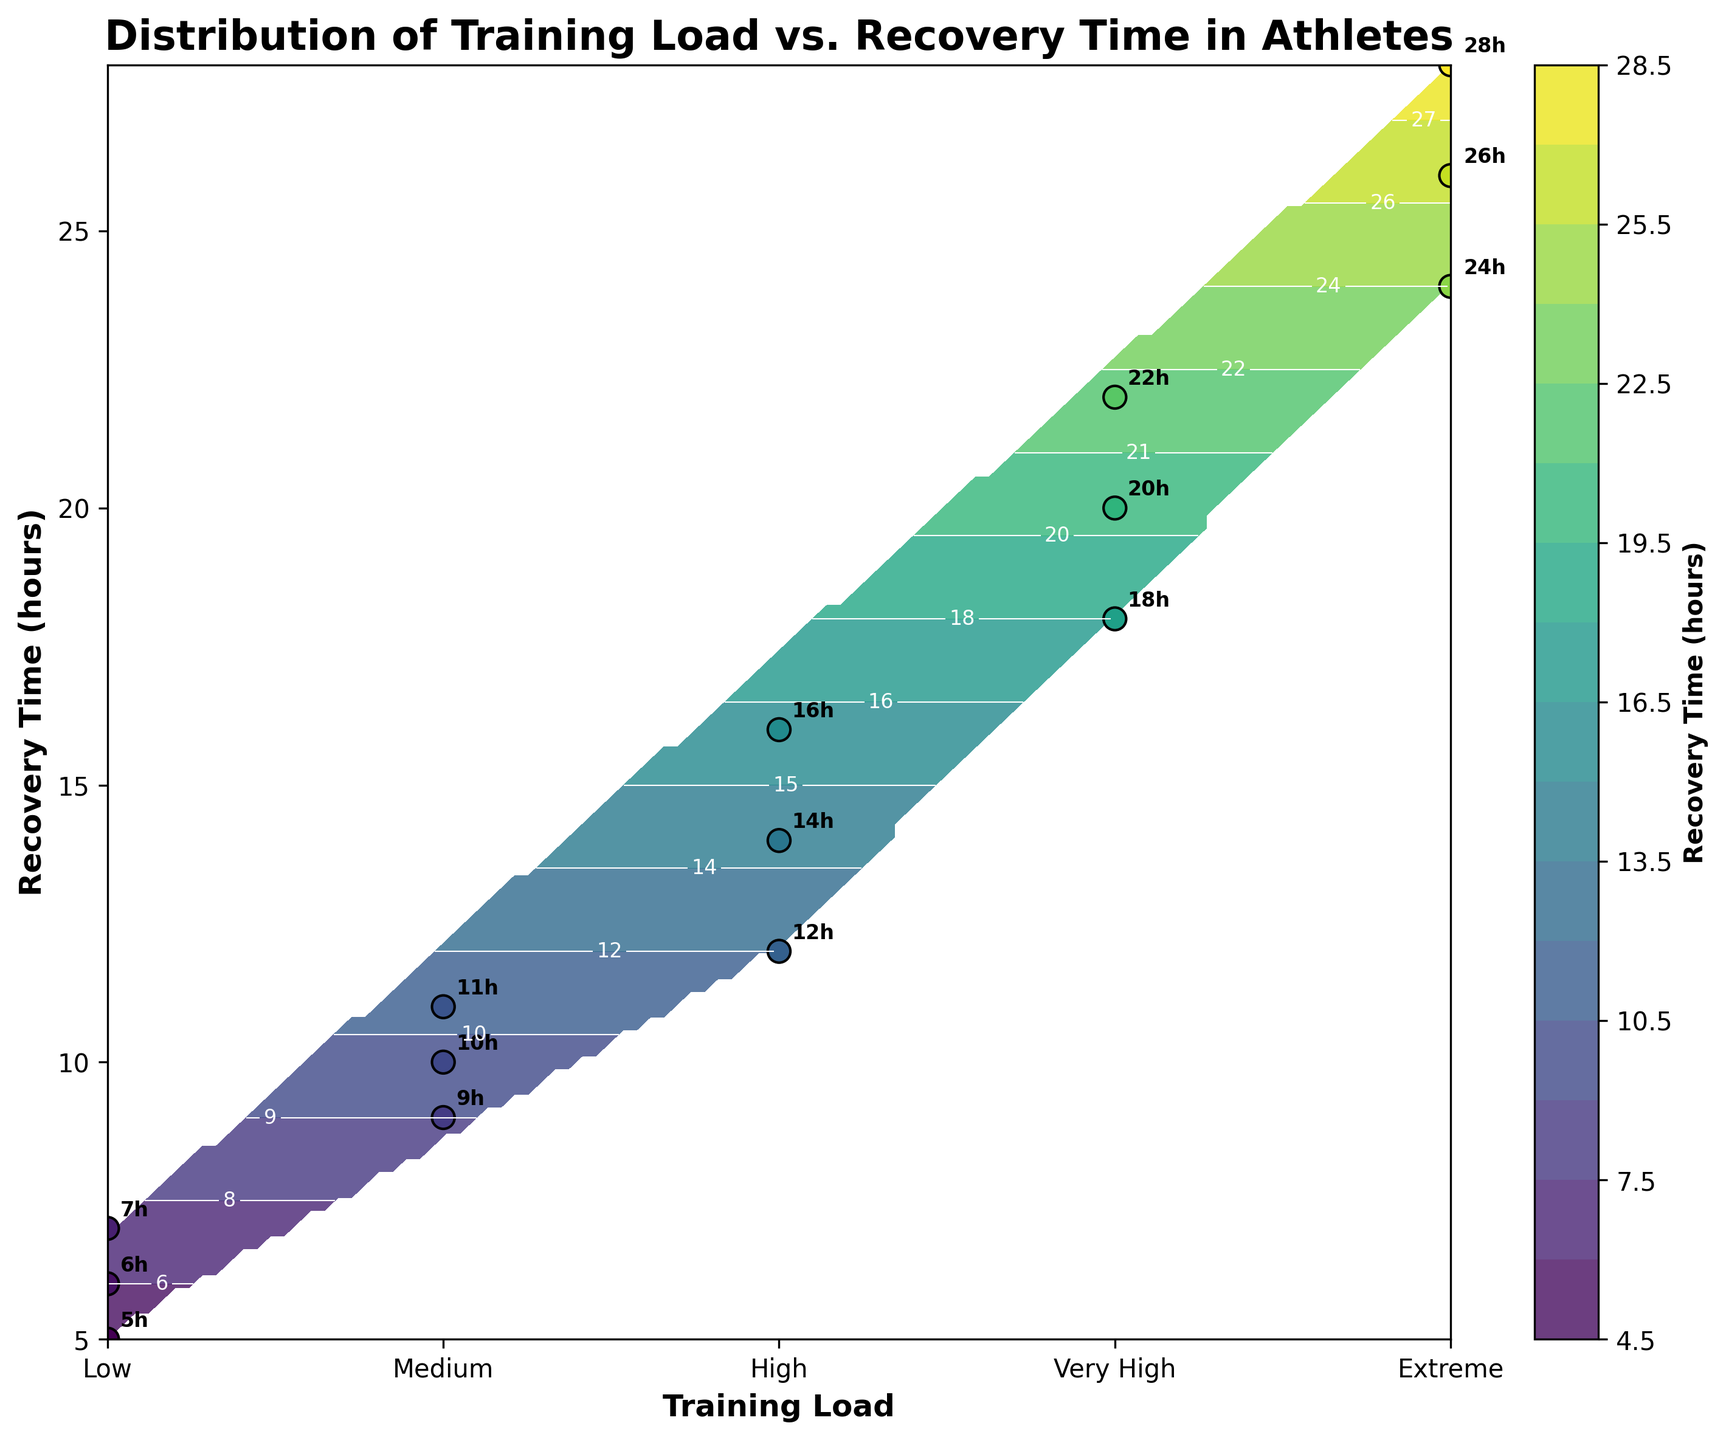What's the title of the plot? The title is displayed at the top of the figure. It is typically in a larger and bold font for emphasis.
Answer: Distribution of Training Load vs. Recovery Time in Athletes How many training load categories are shown in the plot? Check the x-axis ticks and labels. Each distinct label represents a training load category.
Answer: Five (Low, Medium, High, Very High, Extreme) What is the range of recovery times displayed? Look at the y-axis, which marks the range of values for recovery times. Observe the minimum and maximum values on this axis.
Answer: 5 to 28 hours Which training load category has the highest recorded recovery time? Find the maximum value on the y-axis, then refer to the corresponding training load category labeled on the x-axis close to that maximum value.
Answer: Extreme What is the lowest recorded recovery time and in which load category does it occur? Identify the smallest value on the y-axis and observe the corresponding load category on the x-axis nearest to this value.
Answer: 5 hours, Low If we average the recovery times for the 'Medium' training load category, what is the result? Calculate the average by summing the recovery times (10, 9, 11) for 'Medium' and dividing by the number of observations.
Answer: (10 + 9 + 11) / 3 = 10 hours Are the recovery times for 'High' training load generally greater than those for 'Low' training load? Compare the plotted recovery time values for 'High' (ranging from 12 to 16 hours) with those for 'Low' (ranging from 5 to 7 hours).
Answer: Yes In terms of training load categories, which two have the most similar average recovery time? Calculate the average recovery times for each category and compare. For example, 'High' (14, 12, 16) averages (14), and 'Very High' (20, 18, 22) averages (20). Identify the two closest averages.
Answer: High and Very High (average 14, 20) How does the recovery time trend as the training load increases? Observe the contour plot and scatter points. Note the general direction of recovery time values as the load category progresses from Low to Extreme.
Answer: It increases How are individual data points represented in the plot? Look at the markers on the plot that overlay the contour. These typically show the actual measurement points.
Answer: As scatter points with black edges and annotations indicating recovery time in hours 